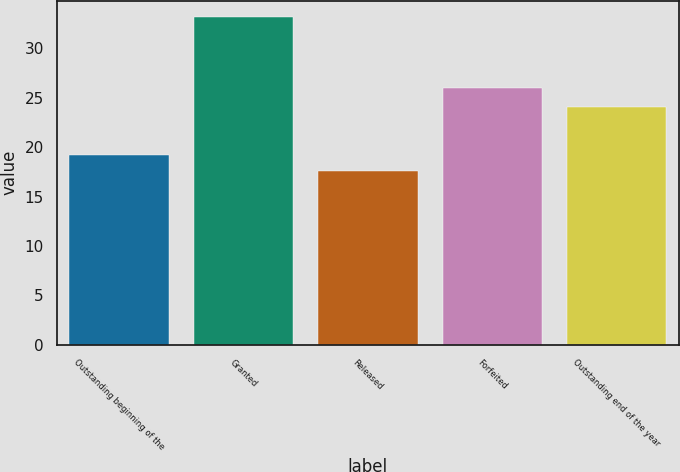Convert chart. <chart><loc_0><loc_0><loc_500><loc_500><bar_chart><fcel>Outstanding beginning of the<fcel>Granted<fcel>Released<fcel>Forfeited<fcel>Outstanding end of the year<nl><fcel>19.16<fcel>33.16<fcel>17.61<fcel>26.03<fcel>24.05<nl></chart> 